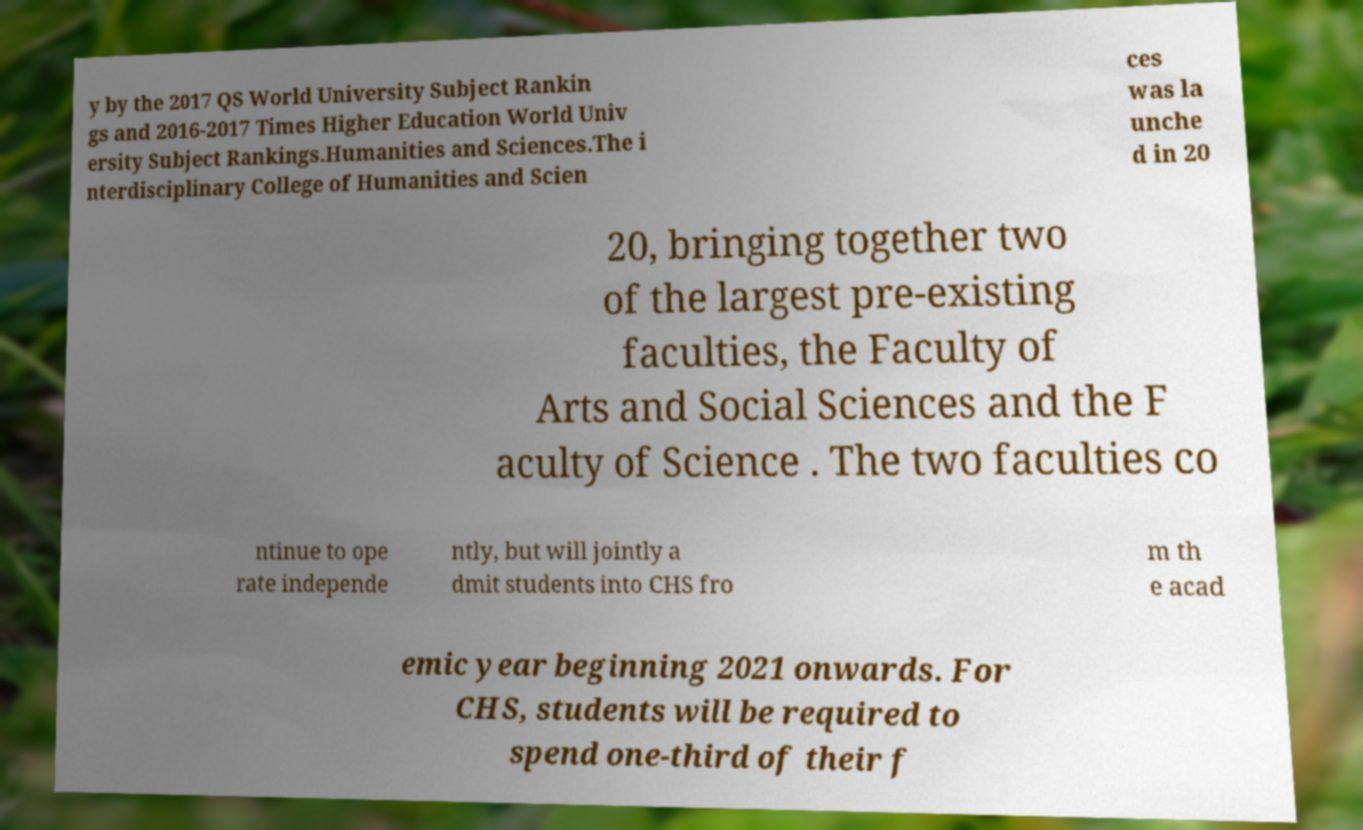I need the written content from this picture converted into text. Can you do that? y by the 2017 QS World University Subject Rankin gs and 2016-2017 Times Higher Education World Univ ersity Subject Rankings.Humanities and Sciences.The i nterdisciplinary College of Humanities and Scien ces was la unche d in 20 20, bringing together two of the largest pre-existing faculties, the Faculty of Arts and Social Sciences and the F aculty of Science . The two faculties co ntinue to ope rate independe ntly, but will jointly a dmit students into CHS fro m th e acad emic year beginning 2021 onwards. For CHS, students will be required to spend one-third of their f 